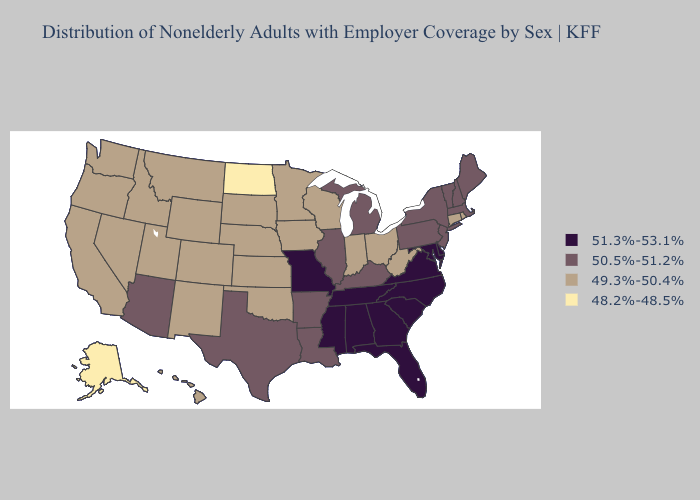Among the states that border Connecticut , does Rhode Island have the highest value?
Concise answer only. No. Does Massachusetts have the lowest value in the Northeast?
Keep it brief. No. Among the states that border Delaware , which have the lowest value?
Concise answer only. New Jersey, Pennsylvania. Does Georgia have the highest value in the South?
Write a very short answer. Yes. Name the states that have a value in the range 49.3%-50.4%?
Give a very brief answer. California, Colorado, Connecticut, Hawaii, Idaho, Indiana, Iowa, Kansas, Minnesota, Montana, Nebraska, Nevada, New Mexico, Ohio, Oklahoma, Oregon, Rhode Island, South Dakota, Utah, Washington, West Virginia, Wisconsin, Wyoming. Does Oklahoma have the lowest value in the South?
Short answer required. Yes. Does North Dakota have the lowest value in the MidWest?
Give a very brief answer. Yes. Which states have the lowest value in the USA?
Quick response, please. Alaska, North Dakota. Is the legend a continuous bar?
Write a very short answer. No. Among the states that border Texas , does Oklahoma have the lowest value?
Answer briefly. Yes. What is the lowest value in the South?
Keep it brief. 49.3%-50.4%. Among the states that border Connecticut , which have the lowest value?
Keep it brief. Rhode Island. Name the states that have a value in the range 49.3%-50.4%?
Quick response, please. California, Colorado, Connecticut, Hawaii, Idaho, Indiana, Iowa, Kansas, Minnesota, Montana, Nebraska, Nevada, New Mexico, Ohio, Oklahoma, Oregon, Rhode Island, South Dakota, Utah, Washington, West Virginia, Wisconsin, Wyoming. Which states have the lowest value in the USA?
Short answer required. Alaska, North Dakota. What is the value of Texas?
Concise answer only. 50.5%-51.2%. 